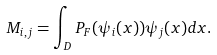Convert formula to latex. <formula><loc_0><loc_0><loc_500><loc_500>M _ { i , j } = \int _ { D } P _ { F } ( \psi _ { i } ( x ) ) \psi _ { j } ( x ) d x .</formula> 